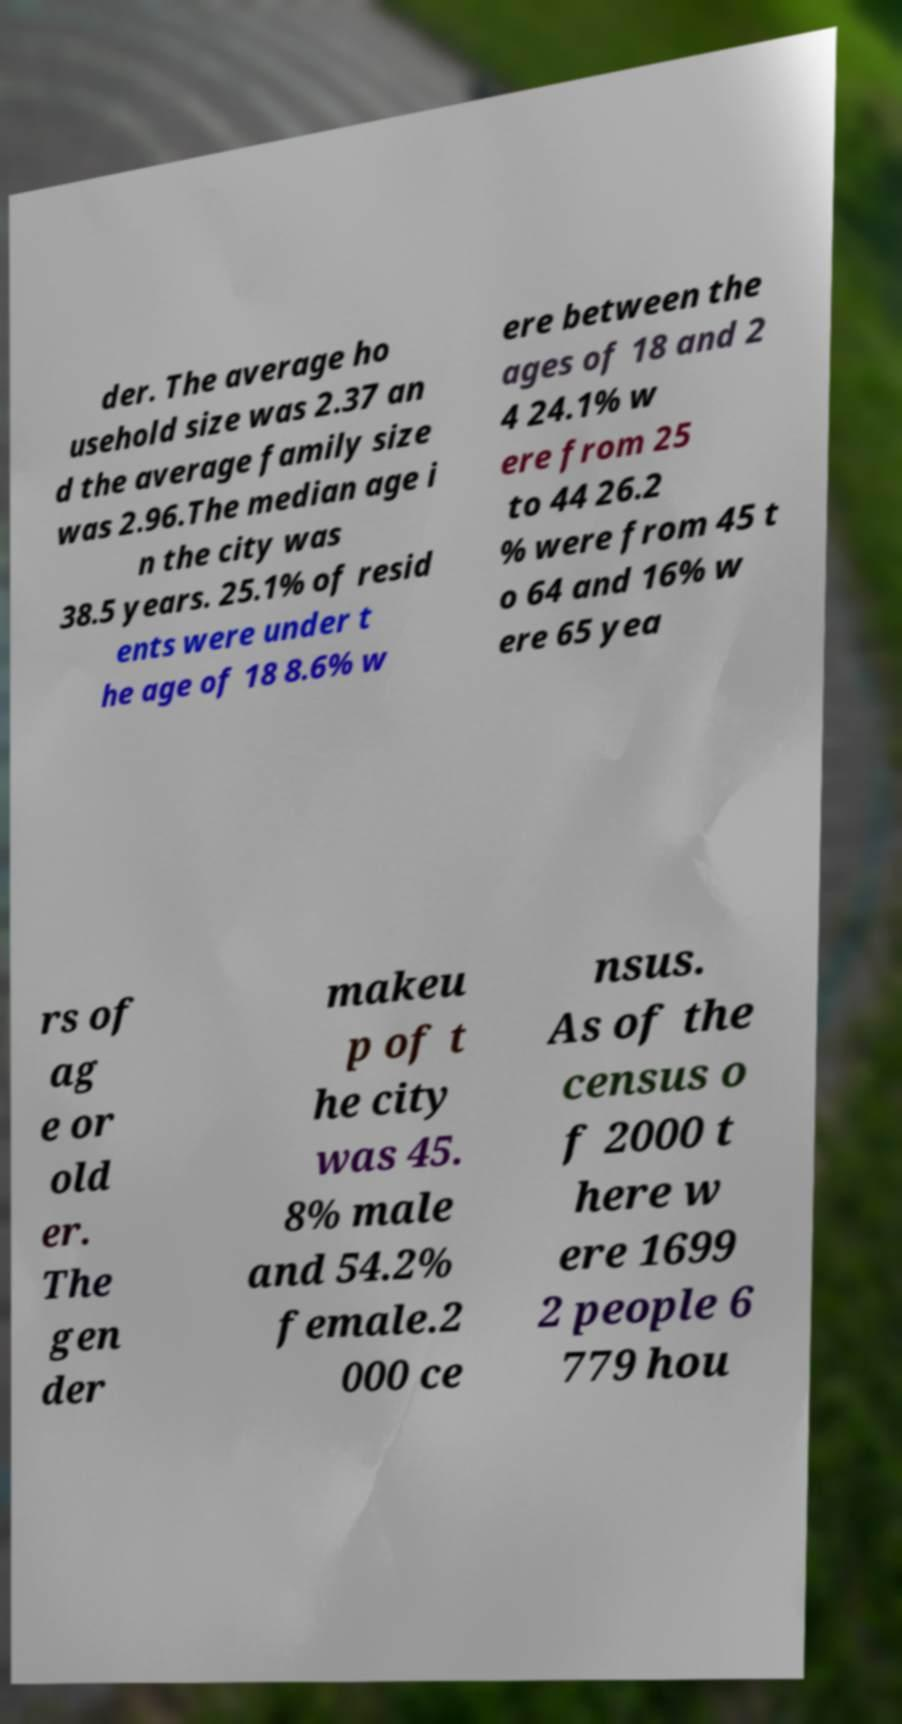Can you accurately transcribe the text from the provided image for me? der. The average ho usehold size was 2.37 an d the average family size was 2.96.The median age i n the city was 38.5 years. 25.1% of resid ents were under t he age of 18 8.6% w ere between the ages of 18 and 2 4 24.1% w ere from 25 to 44 26.2 % were from 45 t o 64 and 16% w ere 65 yea rs of ag e or old er. The gen der makeu p of t he city was 45. 8% male and 54.2% female.2 000 ce nsus. As of the census o f 2000 t here w ere 1699 2 people 6 779 hou 